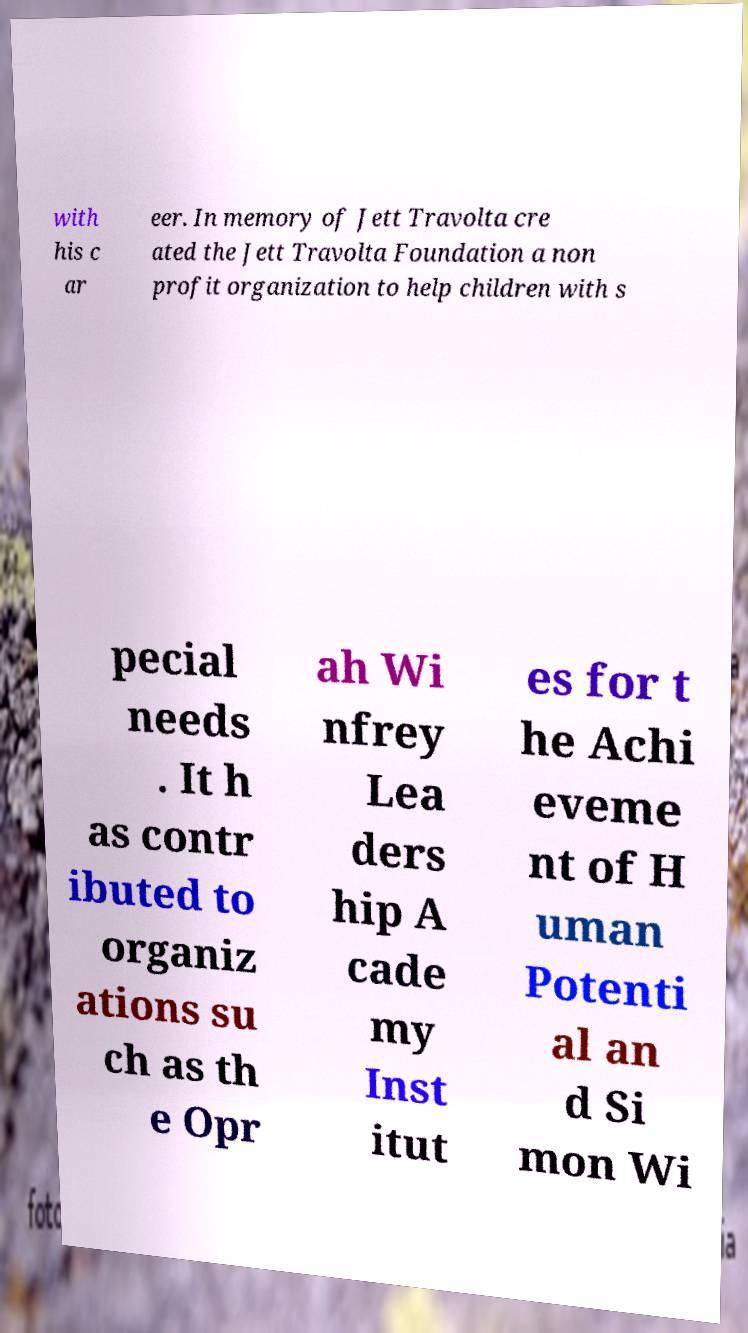Can you accurately transcribe the text from the provided image for me? with his c ar eer. In memory of Jett Travolta cre ated the Jett Travolta Foundation a non profit organization to help children with s pecial needs . It h as contr ibuted to organiz ations su ch as th e Opr ah Wi nfrey Lea ders hip A cade my Inst itut es for t he Achi eveme nt of H uman Potenti al an d Si mon Wi 